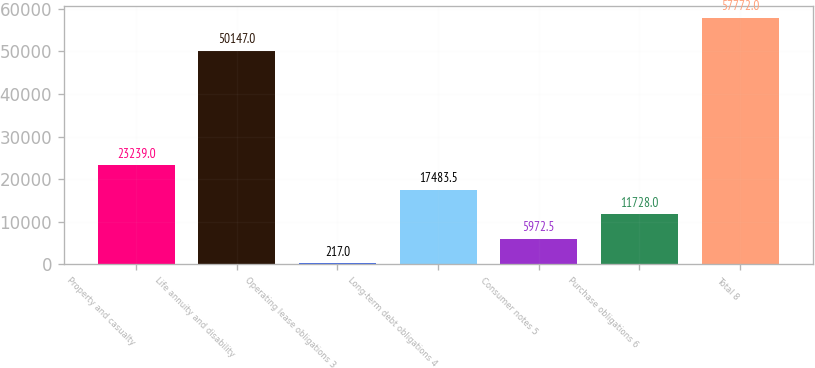Convert chart. <chart><loc_0><loc_0><loc_500><loc_500><bar_chart><fcel>Property and casualty<fcel>Life annuity and disability<fcel>Operating lease obligations 3<fcel>Long-term debt obligations 4<fcel>Consumer notes 5<fcel>Purchase obligations 6<fcel>Total 8<nl><fcel>23239<fcel>50147<fcel>217<fcel>17483.5<fcel>5972.5<fcel>11728<fcel>57772<nl></chart> 